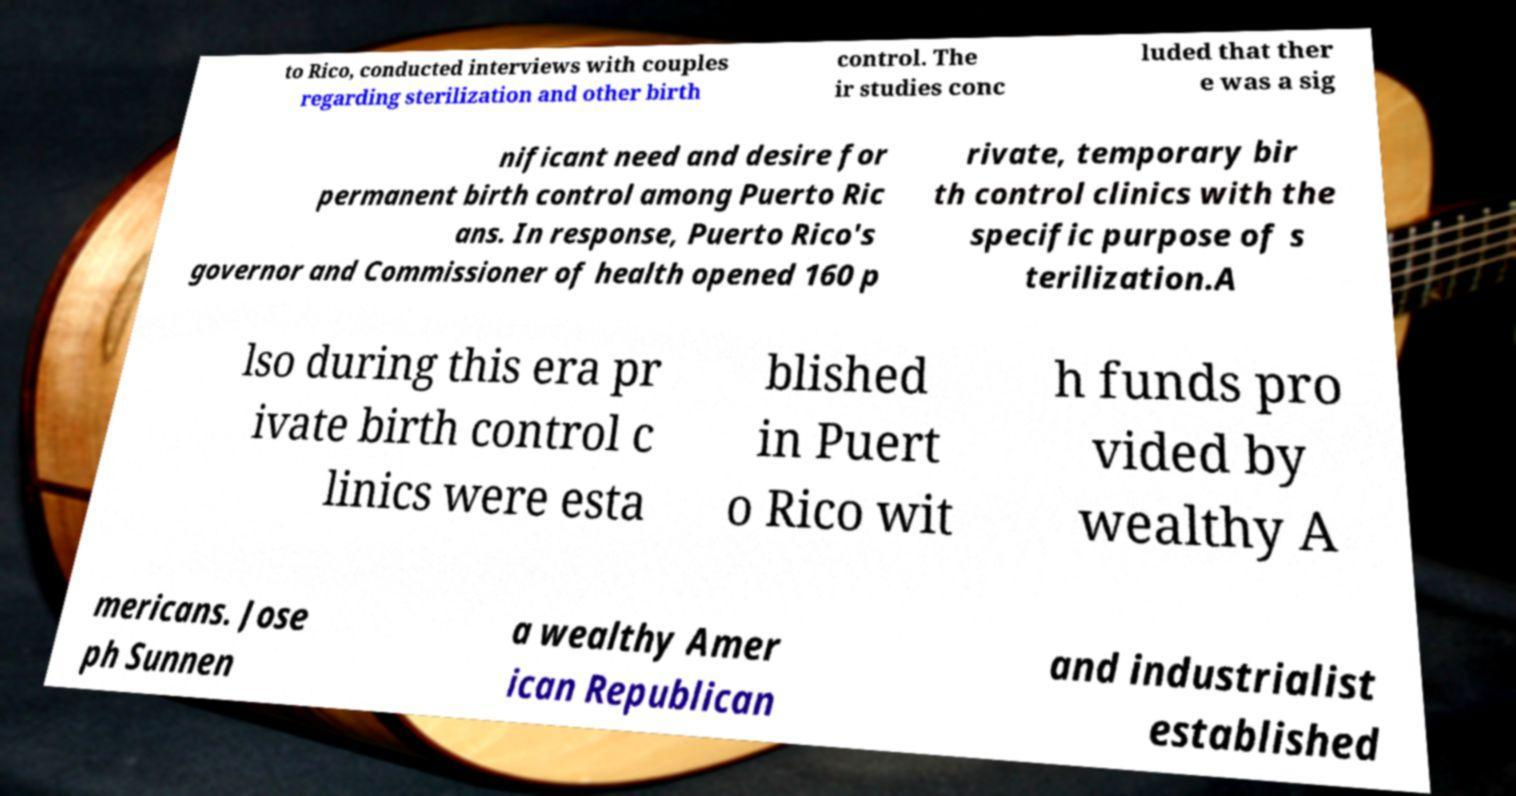What messages or text are displayed in this image? I need them in a readable, typed format. to Rico, conducted interviews with couples regarding sterilization and other birth control. The ir studies conc luded that ther e was a sig nificant need and desire for permanent birth control among Puerto Ric ans. In response, Puerto Rico's governor and Commissioner of health opened 160 p rivate, temporary bir th control clinics with the specific purpose of s terilization.A lso during this era pr ivate birth control c linics were esta blished in Puert o Rico wit h funds pro vided by wealthy A mericans. Jose ph Sunnen a wealthy Amer ican Republican and industrialist established 